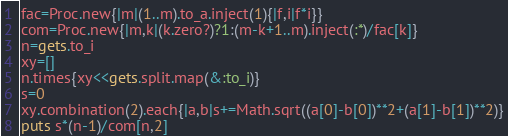Convert code to text. <code><loc_0><loc_0><loc_500><loc_500><_Ruby_>fac=Proc.new{|m|(1..m).to_a.inject(1){|f,i|f*i}}
com=Proc.new{|m,k|(k.zero?)?1:(m-k+1..m).inject(:*)/fac[k]}
n=gets.to_i
xy=[]
n.times{xy<<gets.split.map(&:to_i)}
s=0
xy.combination(2).each{|a,b|s+=Math.sqrt((a[0]-b[0])**2+(a[1]-b[1])**2)}
puts s*(n-1)/com[n,2]</code> 